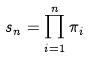Convert formula to latex. <formula><loc_0><loc_0><loc_500><loc_500>s _ { n } = \prod _ { i = 1 } ^ { n } \pi _ { i }</formula> 